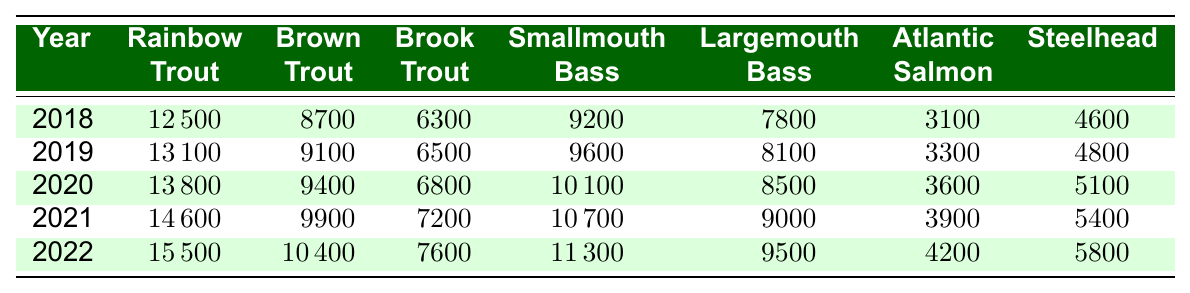What's the population of Rainbow Trout in 2022? The table shows the population of Rainbow Trout for each year. In 2022, the recorded population is 15500.
Answer: 15500 What is the lowest population recorded for Brown Trout? By examining the data, the lowest population of Brown Trout is in 2018, with 8700 individuals.
Answer: 8700 How many more Smallmouth Bass were there in 2021 than in 2018? In 2021, the population of Smallmouth Bass was 10700, and in 2018 it was 9200. The difference is 10700 - 9200 = 1500.
Answer: 1500 What is the total fish population for Atlantic Salmon from 2018 to 2022? To find the total population for Atlantic Salmon over the five years, we add the populations: 3100 + 3300 + 3600 + 3900 + 4200 = 18100.
Answer: 18100 In which year did the population of Brook Trout first exceed 7000? Looking at the data, the population of Brook Trout reached 7200 in 2021, which is the first time it exceeded 7000.
Answer: 2021 What's the average population of Largemouth Bass across these years? The populations of Largemouth Bass are 7800, 8100, 8500, 9000, and 9500. The average can be calculated by summing (7800 + 8100 + 8500 + 9000 + 9500 = 42900), then dividing by 5, giving an average of 8580.
Answer: 8580 Did the population of Steelhead increase every year from 2018 to 2022? Checking each year, Steelhead populations are: 4600 (2018), 4800 (2019), 5100 (2020), 5400 (2021), and 5800 (2022). All values are increasing from one year to the next, indicating a continual rise.
Answer: Yes Which fish species had the greatest population increase from 2018 to 2022? By comparing the populations, Rainbow Trout increased from 12500 to 15500, which is an increase of 3000. This is the largest increase among all species listed.
Answer: Rainbow Trout What was the population of Brown Trout in 2020 compared to the population of Smallmouth Bass in 2021? In 2020, the population of Brown Trout was 9400, while Smallmouth Bass was 10700 in 2021. The comparison shows Smallmouth Bass had a higher population by 1300.
Answer: 1300 Was the population of Atlantic Salmon higher in 2021 than in 2019? By looking at the numbers, Atlantic Salmon populations were 3300 in 2019 and 3900 in 2021. Since 3900 is greater than 3300, the population was indeed higher in 2021.
Answer: Yes 